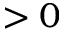<formula> <loc_0><loc_0><loc_500><loc_500>> 0</formula> 